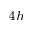Convert formula to latex. <formula><loc_0><loc_0><loc_500><loc_500>_ { 4 h }</formula> 